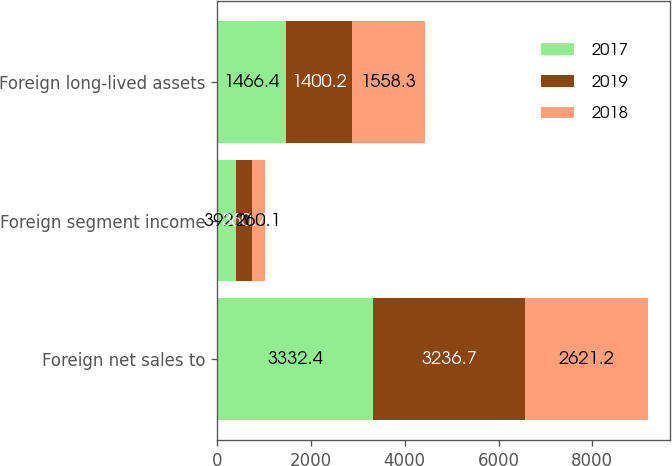Convert chart. <chart><loc_0><loc_0><loc_500><loc_500><stacked_bar_chart><ecel><fcel>Foreign net sales to<fcel>Foreign segment income<fcel>Foreign long-lived assets<nl><fcel>2017<fcel>3332.4<fcel>392.3<fcel>1466.4<nl><fcel>2019<fcel>3236.7<fcel>360.7<fcel>1400.2<nl><fcel>2018<fcel>2621.2<fcel>260.1<fcel>1558.3<nl></chart> 